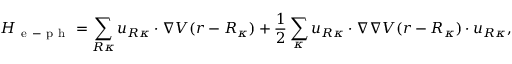<formula> <loc_0><loc_0><loc_500><loc_500>H _ { e - p h } = \sum _ { R \kappa } u _ { R \kappa } \cdot \nabla V ( r - R _ { \kappa } ) + \frac { 1 } { 2 } \sum _ { \kappa } u _ { R \kappa } \cdot \nabla \nabla V ( r - R _ { \kappa } ) \cdot u _ { R \kappa } ,</formula> 